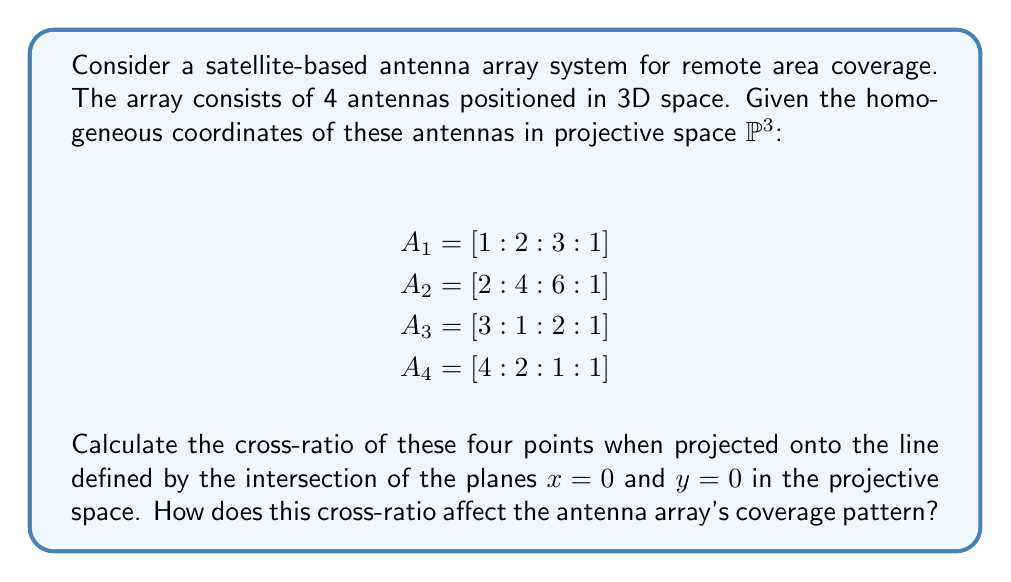Teach me how to tackle this problem. To solve this problem, we'll follow these steps:

1) First, we need to project the points onto the line defined by the intersection of planes $x = 0$ and $y = 0$. This line corresponds to the z-axis in the affine space.

2) To project the points, we'll keep only the z and w coordinates:

   $A_1' = [3 : 1]$
   $A_2' = [6 : 1]$
   $A_3' = [2 : 1]$
   $A_4' = [1 : 1]$

3) Now, we need to calculate the cross-ratio of these four points. The cross-ratio of four collinear points $A, B, C, D$ is defined as:

   $$(A, B; C, D) = \frac{(C-A)(D-B)}{(C-B)(D-A)}$$

4) In projective coordinates $[z : w]$, we can calculate the differences as:

   $C - A = [z_C w_A - z_A w_C : w_C w_A]$

5) Let's calculate all the differences:

   $A_3' - A_1' = [2 \cdot 1 - 3 \cdot 1 : 1 \cdot 1] = [-1 : 1]$
   $A_4' - A_2' = [1 \cdot 1 - 6 \cdot 1 : 1 \cdot 1] = [-5 : 1]$
   $A_3' - A_2' = [2 \cdot 1 - 6 \cdot 1 : 1 \cdot 1] = [-4 : 1]$
   $A_4' - A_1' = [1 \cdot 1 - 3 \cdot 1 : 1 \cdot 1] = [-2 : 1]$

6) Now we can calculate the cross-ratio:

   $$(A_1', A_2'; A_3', A_4') = \frac{(-1)(-5)}{(-4)(-2)} = \frac{5}{8}$$

7) The cross-ratio of 5/8 indicates that the antennas are not harmonically separated along this projection. This non-harmonic separation can lead to an uneven coverage pattern.

8) In antenna array design, the cross-ratio can affect the beam pattern and directivity. A cross-ratio different from 1 (which would indicate a harmonic separation) suggests that the antenna array will have an asymmetric radiation pattern along this axis.

9) This asymmetry could be beneficial for targeting specific remote areas with stronger signal strength, but it might also create zones of weaker coverage in other areas.
Answer: $\frac{5}{8}$, indicating non-harmonic separation and potential asymmetric coverage. 